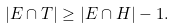Convert formula to latex. <formula><loc_0><loc_0><loc_500><loc_500>| E \cap T | \geq | E \cap H | - 1 .</formula> 